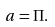<formula> <loc_0><loc_0><loc_500><loc_500>a = \Pi .</formula> 